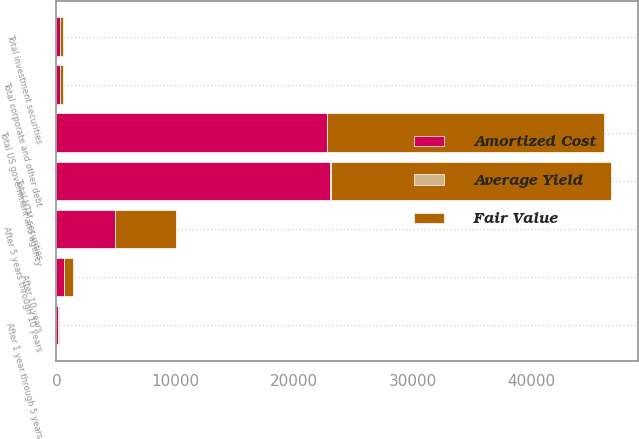<chart> <loc_0><loc_0><loc_500><loc_500><stacked_bar_chart><ecel><fcel>After 5 years through 10 years<fcel>After 10 years<fcel>Total US government and agency<fcel>After 1 year through 5 years<fcel>Total corporate and other debt<fcel>Total HTM securities<fcel>Total investment securities<nl><fcel>Fair Value<fcel>5113<fcel>727<fcel>23310<fcel>95<fcel>289<fcel>23599<fcel>289<nl><fcel>Amortized Cost<fcel>4923<fcel>666<fcel>22792<fcel>95<fcel>289<fcel>23081<fcel>289<nl><fcel>Average Yield<fcel>1.9<fcel>2.3<fcel>2.3<fcel>3.6<fcel>0.1<fcel>2.1<fcel>1.7<nl></chart> 